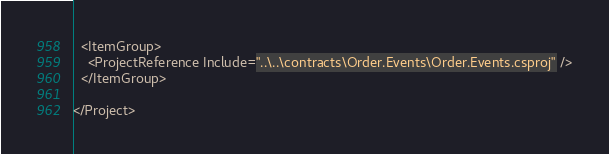<code> <loc_0><loc_0><loc_500><loc_500><_XML_>  <ItemGroup>
    <ProjectReference Include="..\..\contracts\Order.Events\Order.Events.csproj" />
  </ItemGroup>

</Project>
</code> 